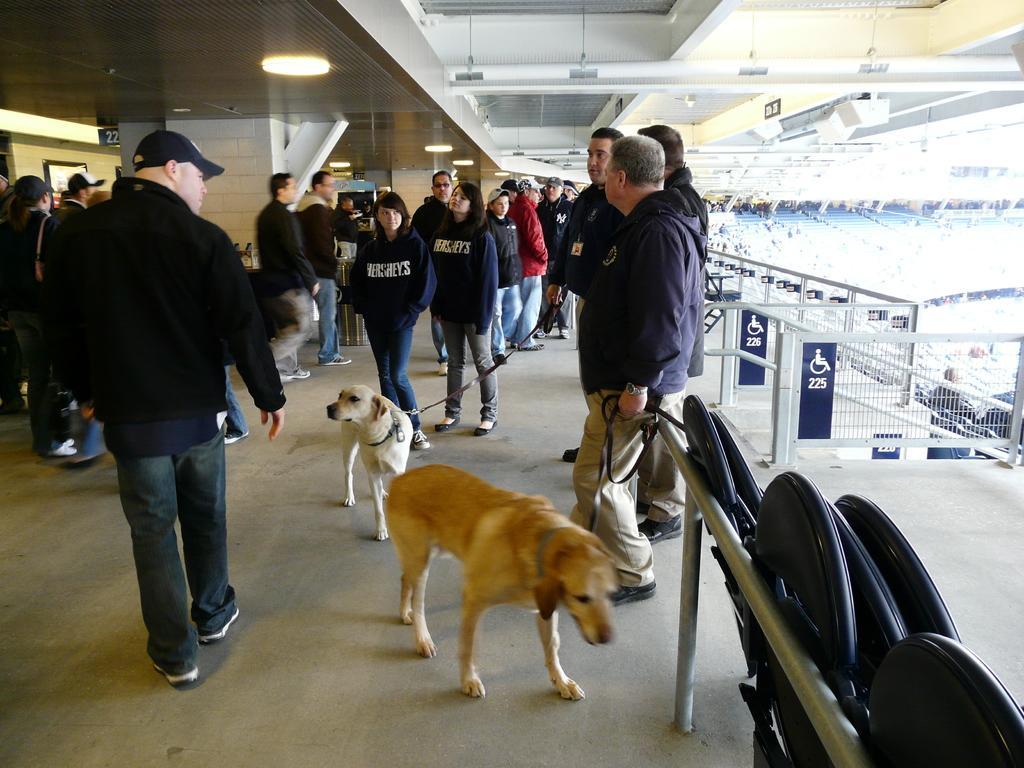Could you give a brief overview of what you see in this image? This is the picture of stadium in which on the floor there are some people standing and some dogs. 